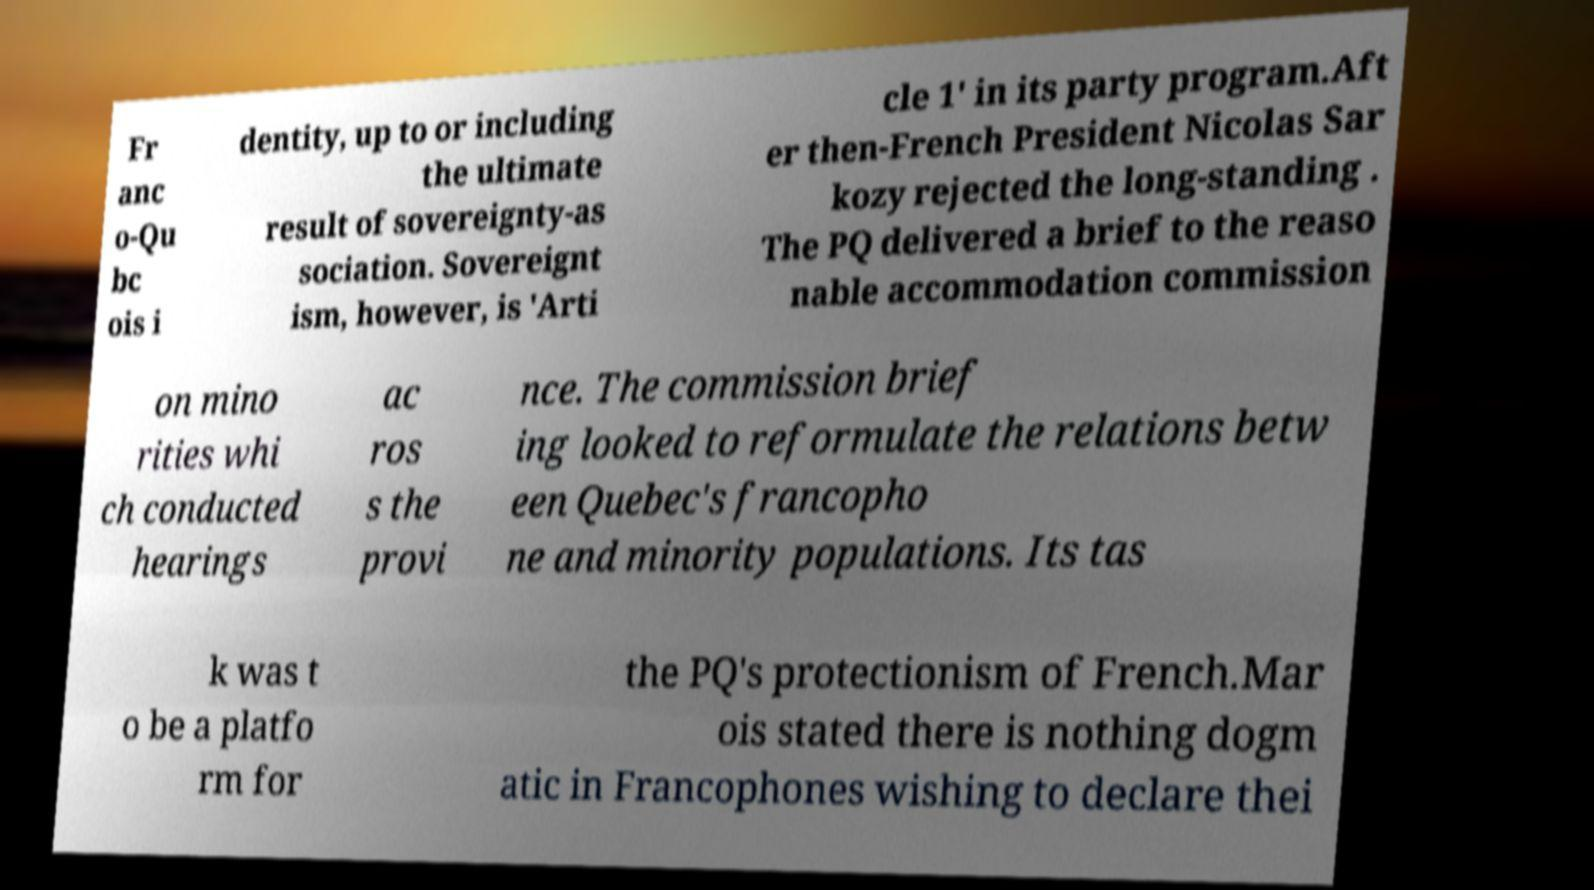For documentation purposes, I need the text within this image transcribed. Could you provide that? Fr anc o-Qu bc ois i dentity, up to or including the ultimate result of sovereignty-as sociation. Sovereignt ism, however, is 'Arti cle 1' in its party program.Aft er then-French President Nicolas Sar kozy rejected the long-standing . The PQ delivered a brief to the reaso nable accommodation commission on mino rities whi ch conducted hearings ac ros s the provi nce. The commission brief ing looked to reformulate the relations betw een Quebec's francopho ne and minority populations. Its tas k was t o be a platfo rm for the PQ's protectionism of French.Mar ois stated there is nothing dogm atic in Francophones wishing to declare thei 